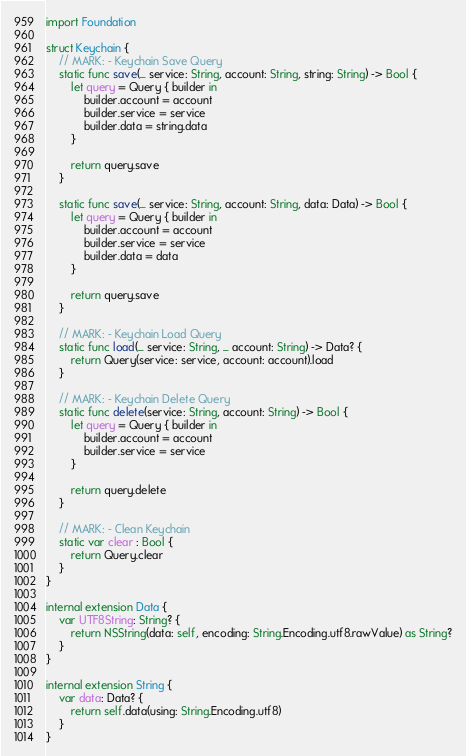Convert code to text. <code><loc_0><loc_0><loc_500><loc_500><_Swift_>import Foundation

struct Keychain {
    // MARK: - Keychain Save Query
    static func save(_ service: String, account: String, string: String) -> Bool {
        let query = Query { builder in
            builder.account = account
            builder.service = service
            builder.data = string.data
        }
        
        return query.save
    }
    
    static func save(_ service: String, account: String, data: Data) -> Bool {
        let query = Query { builder in
            builder.account = account
            builder.service = service
            builder.data = data
        }
        
        return query.save
    }
    
    // MARK: - Keychain Load Query
    static func load(_ service: String, _ account: String) -> Data? {
        return Query(service: service, account: account).load
    }
    
    // MARK: - Keychain Delete Query
    static func delete(service: String, account: String) -> Bool {
        let query = Query { builder in
            builder.account = account
            builder.service = service
        }
        
        return query.delete
    }
    
    // MARK: - Clean Keychain
    static var clear : Bool {
        return Query.clear
    }
}

internal extension Data {
    var UTF8String: String? {
        return NSString(data: self, encoding: String.Encoding.utf8.rawValue) as String?
    }
}

internal extension String {
    var data: Data? {
        return self.data(using: String.Encoding.utf8)
    }
}
</code> 